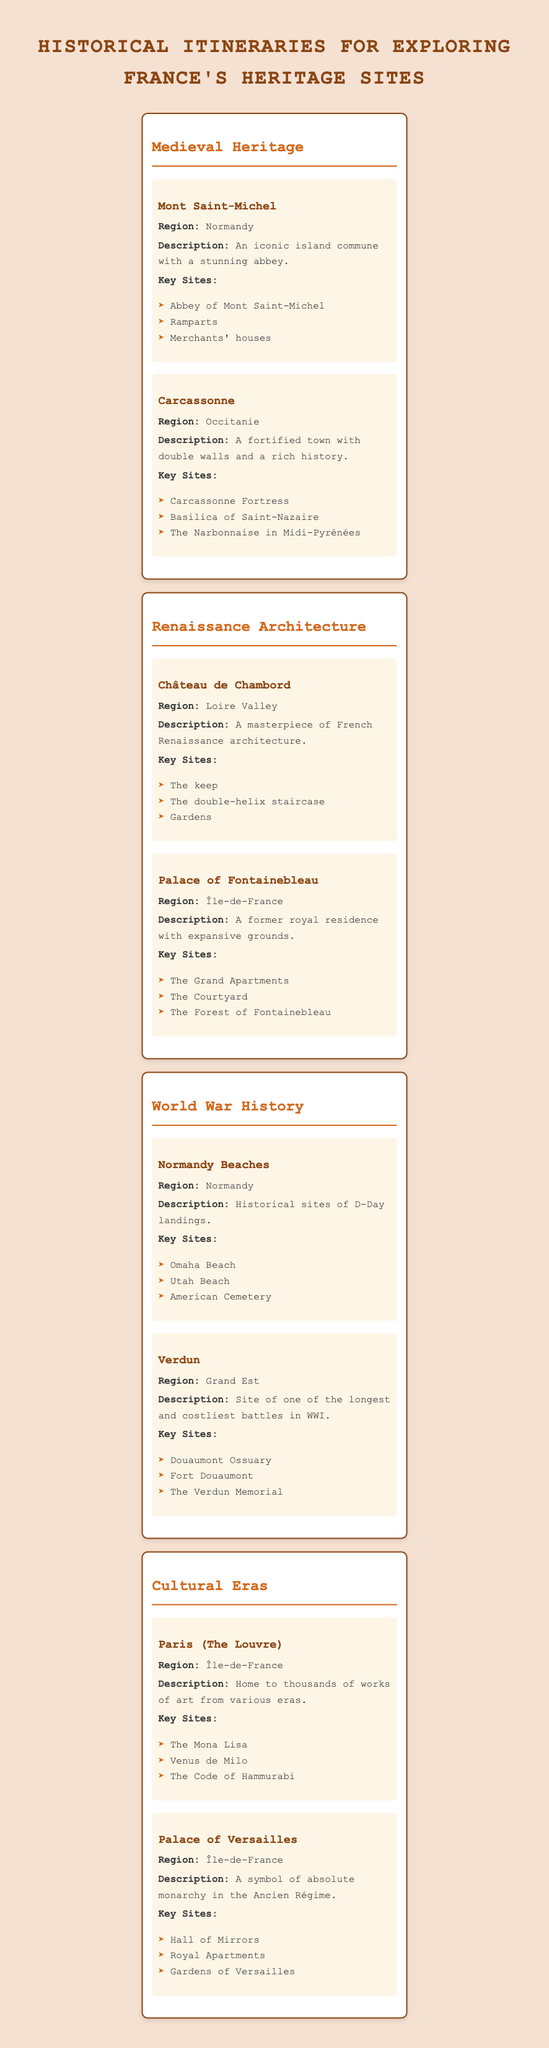What is the description of Mont Saint-Michel? The table lists Mont Saint-Michel under the Medieval Heritage category, stating that it is "An iconic island commune with a stunning abbey."
Answer: An iconic island commune with a stunning abbey Which region is the Palace of Versailles located in? Referring to the table, the Palace of Versailles is listed under the Cultural Eras category, and its region is specified as "Île-de-France."
Answer: Île-de-France How many key sites are listed for Carcassonne? In the table, Carcassonne has three key sites mentioned: Carcassonne Fortress, Basilica of Saint-Nazaire, and The Narbonnaise in Midi-Pyrénées. Thus, the count is three.
Answer: Three Is the Château de Chambord part of the Renaissance Architecture category? The table categorizes Château de Chambord under Renaissance Architecture, which confirms that it is indeed part of this category.
Answer: Yes What are the key sites for the Normandy Beaches? The key sites listed under the Normandy Beaches destination include Omaha Beach, Utah Beach, and American Cemetery.
Answer: Omaha Beach, Utah Beach, American Cemetery Compare the number of key sites listed for the Palace of Fontainebleau and Mont Saint-Michel. The Palace of Fontainebleau has three key sites: The Grand Apartments, The Courtyard, and The Forest of Fontainebleau. Mont Saint-Michel also has three key sites: Abbey of Mont Saint-Michel, Ramparts, and Merchants' houses. Since both have three sites, they are equal.
Answer: Equal (three key sites each) What is the total number of destinations listed under the World War History category? Under the World War History category, there are two destinations listed: Normandy Beaches and Verdun. Thus, the total number is two.
Answer: Two Which region has the most destinations listed in this table? By reviewing the table, Île-de-France has three destinations (Palace of Fontainebleau, Paris (The Louvre), and Palace of Versailles), while other regions have fewer. Therefore, Île-de-France has the most.
Answer: Île-de-France What is the combined number of key sites for both destinations in the Medieval Heritage category? Mont Saint-Michel has three key sites, and Carcassonne also has three key sites. Adding these gives a total of 3 + 3 = 6 key sites for both destinations in the Medieval Heritage category.
Answer: Six 